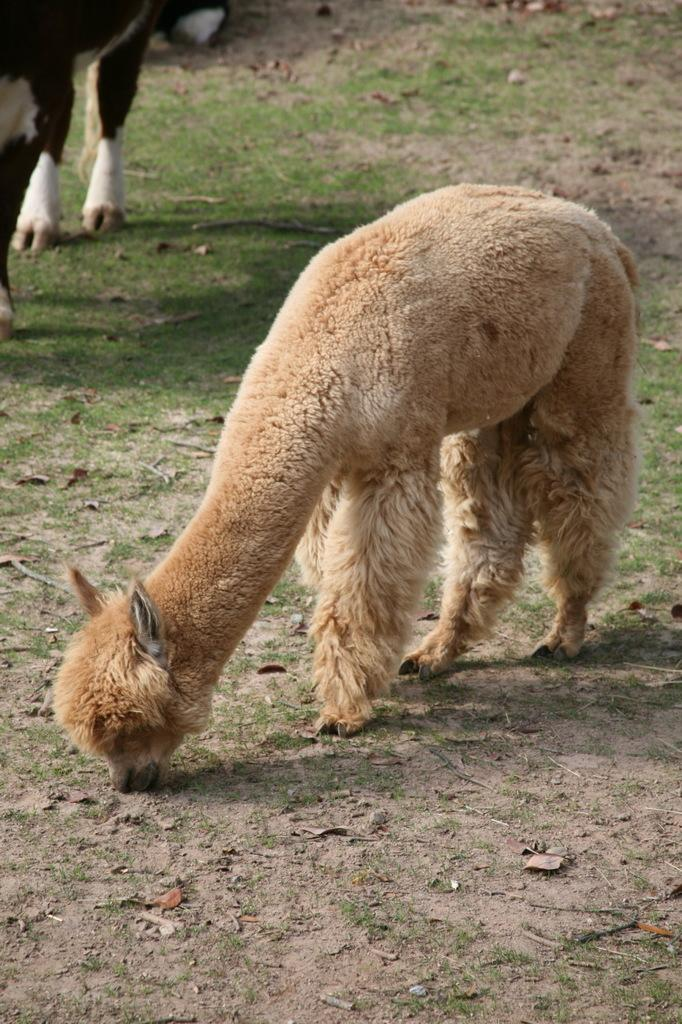What is the main subject in the center of the image? There is an animal in the center of the image. What type of terrain is visible in the background of the image? There is grass on the ground in the background of the image. Are there any other animals present in the image? Yes, there is another animal in the background of the image. What type of marble can be seen in the image? There is no marble present in the image. How many thumbs does the animal in the center have? Animals do not have thumbs, so this question cannot be answered definitively from the image. 